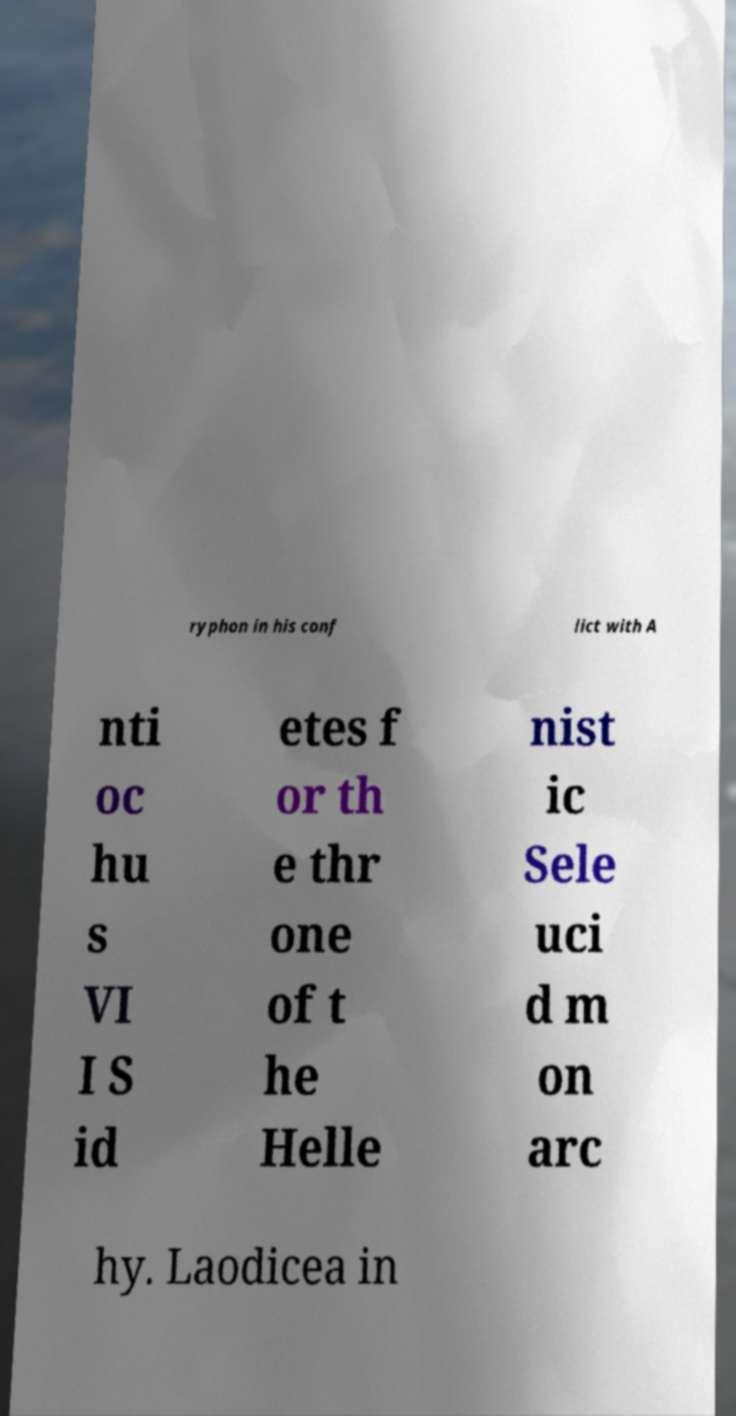What messages or text are displayed in this image? I need them in a readable, typed format. ryphon in his conf lict with A nti oc hu s VI I S id etes f or th e thr one of t he Helle nist ic Sele uci d m on arc hy. Laodicea in 